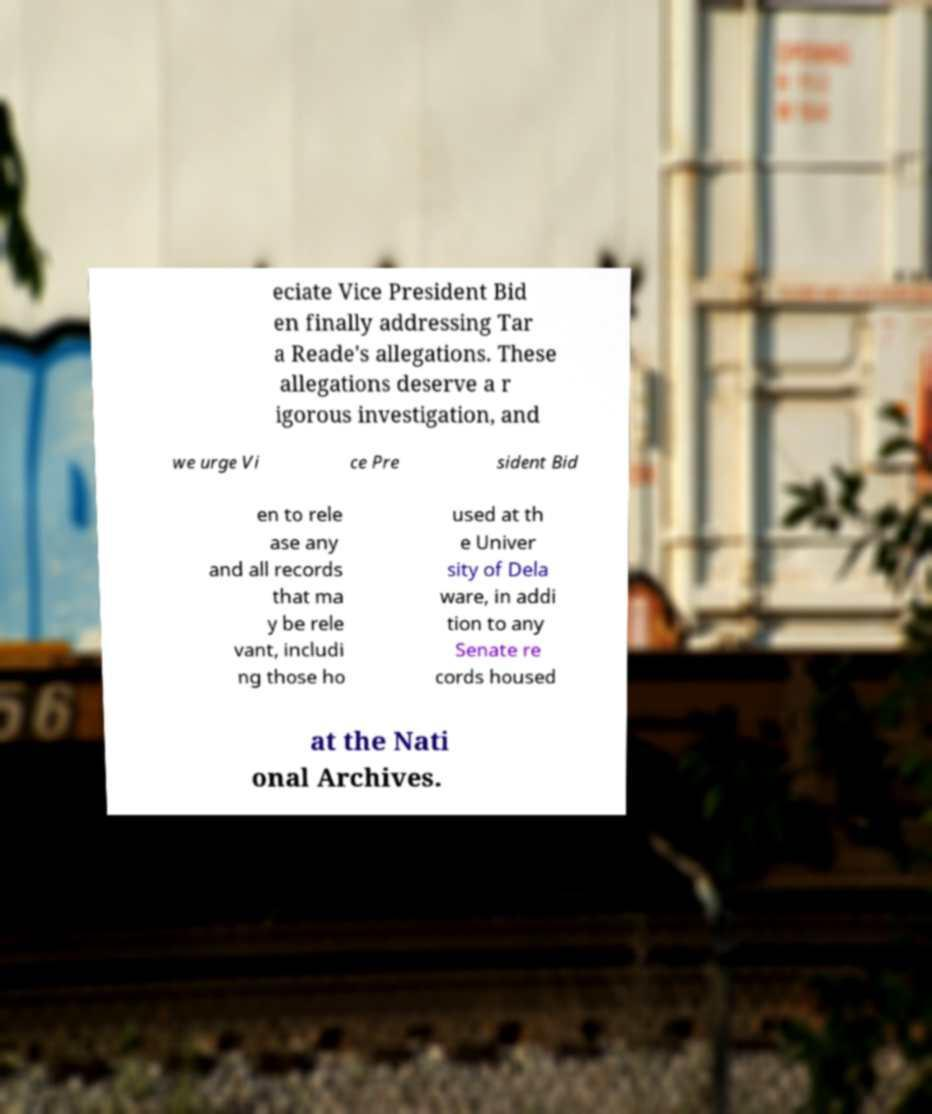Can you accurately transcribe the text from the provided image for me? eciate Vice President Bid en finally addressing Tar a Reade's allegations. These allegations deserve a r igorous investigation, and we urge Vi ce Pre sident Bid en to rele ase any and all records that ma y be rele vant, includi ng those ho used at th e Univer sity of Dela ware, in addi tion to any Senate re cords housed at the Nati onal Archives. 